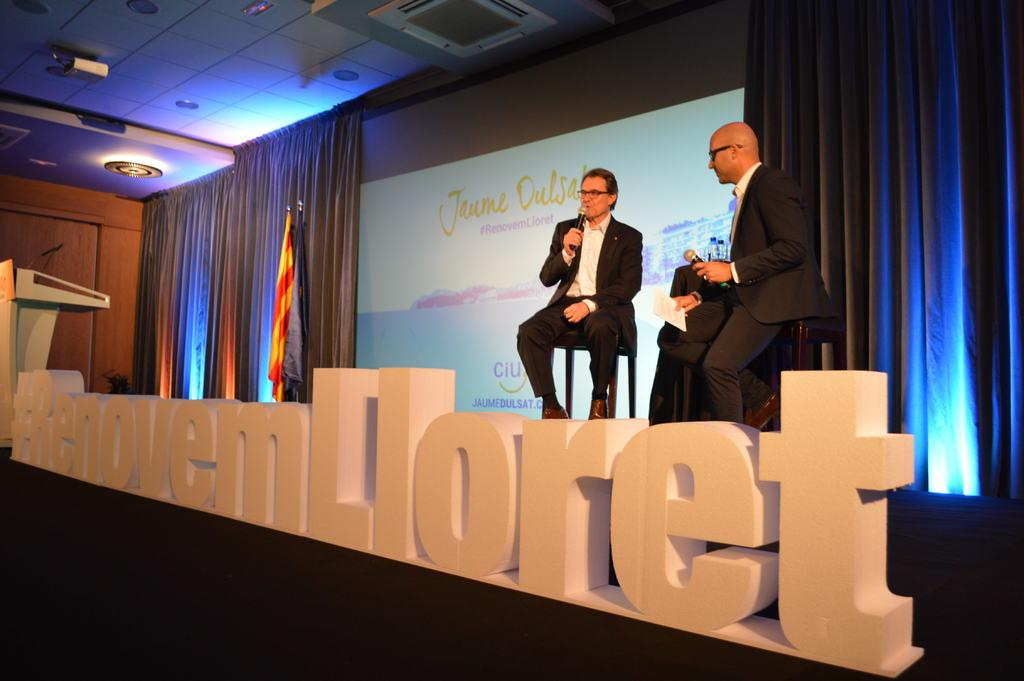<image>
Offer a succinct explanation of the picture presented. Two men sitting on stools on a stage in front of a sign with the name Jaume written on it. 